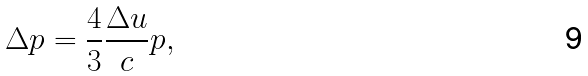Convert formula to latex. <formula><loc_0><loc_0><loc_500><loc_500>\Delta p = \frac { 4 } { 3 } \frac { \Delta u } { c } p ,</formula> 